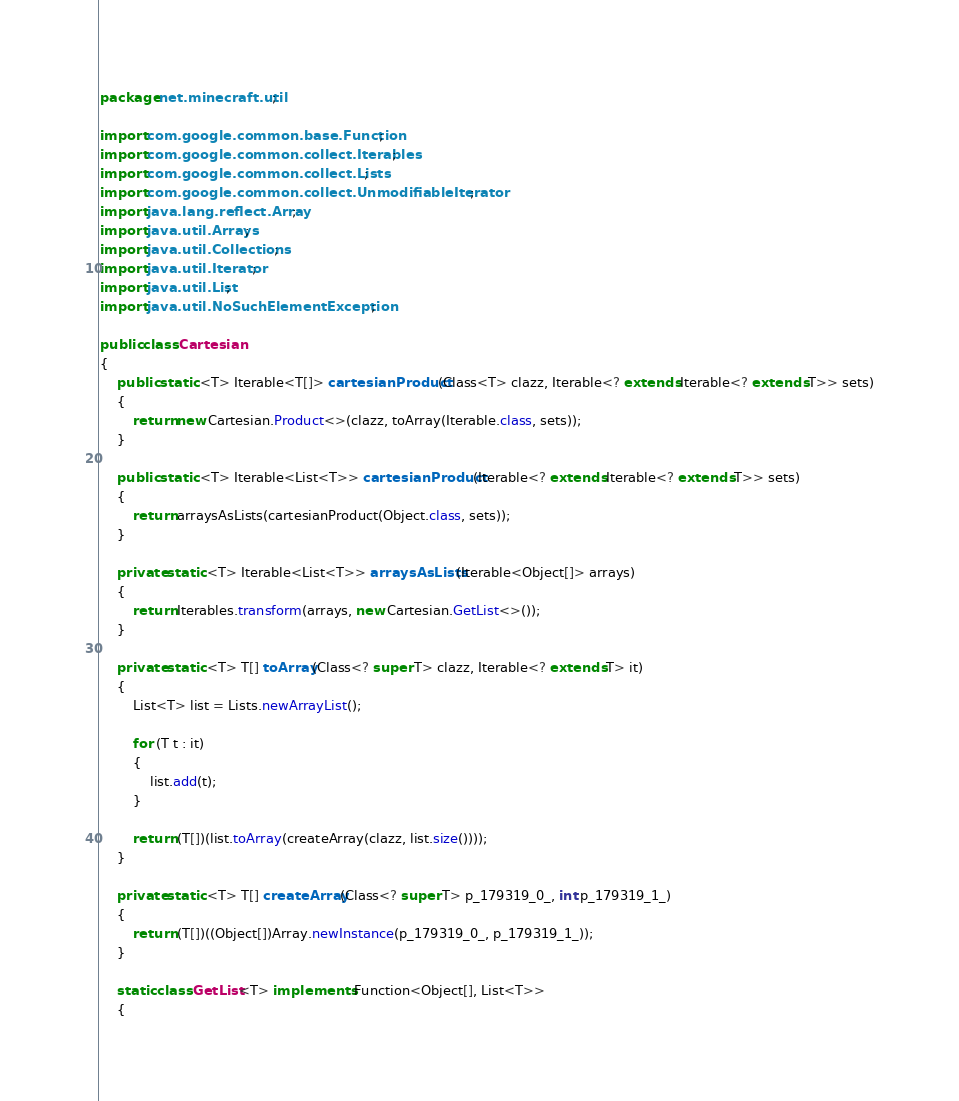<code> <loc_0><loc_0><loc_500><loc_500><_Java_>package net.minecraft.util;

import com.google.common.base.Function;
import com.google.common.collect.Iterables;
import com.google.common.collect.Lists;
import com.google.common.collect.UnmodifiableIterator;
import java.lang.reflect.Array;
import java.util.Arrays;
import java.util.Collections;
import java.util.Iterator;
import java.util.List;
import java.util.NoSuchElementException;

public class Cartesian
{
    public static <T> Iterable<T[]> cartesianProduct(Class<T> clazz, Iterable<? extends Iterable<? extends T>> sets)
    {
        return new Cartesian.Product<>(clazz, toArray(Iterable.class, sets));
    }

    public static <T> Iterable<List<T>> cartesianProduct(Iterable<? extends Iterable<? extends T>> sets)
    {
        return arraysAsLists(cartesianProduct(Object.class, sets));
    }

    private static <T> Iterable<List<T>> arraysAsLists(Iterable<Object[]> arrays)
    {
        return Iterables.transform(arrays, new Cartesian.GetList<>());
    }

    private static <T> T[] toArray(Class<? super T> clazz, Iterable<? extends T> it)
    {
        List<T> list = Lists.newArrayList();

        for (T t : it)
        {
            list.add(t);
        }

        return (T[])(list.toArray(createArray(clazz, list.size())));
    }

    private static <T> T[] createArray(Class<? super T> p_179319_0_, int p_179319_1_)
    {
        return (T[])((Object[])Array.newInstance(p_179319_0_, p_179319_1_));
    }

    static class GetList<T> implements Function<Object[], List<T>>
    {</code> 